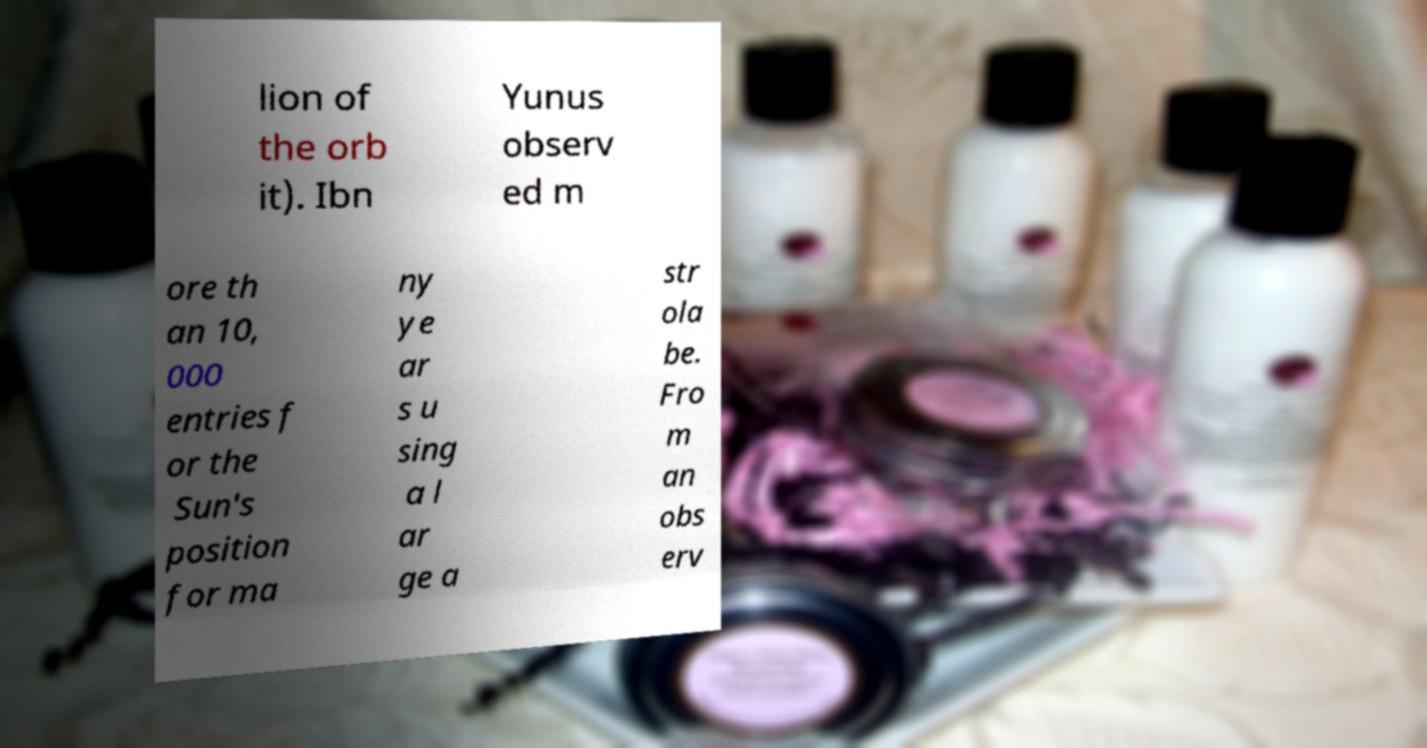For documentation purposes, I need the text within this image transcribed. Could you provide that? lion of the orb it). Ibn Yunus observ ed m ore th an 10, 000 entries f or the Sun's position for ma ny ye ar s u sing a l ar ge a str ola be. Fro m an obs erv 